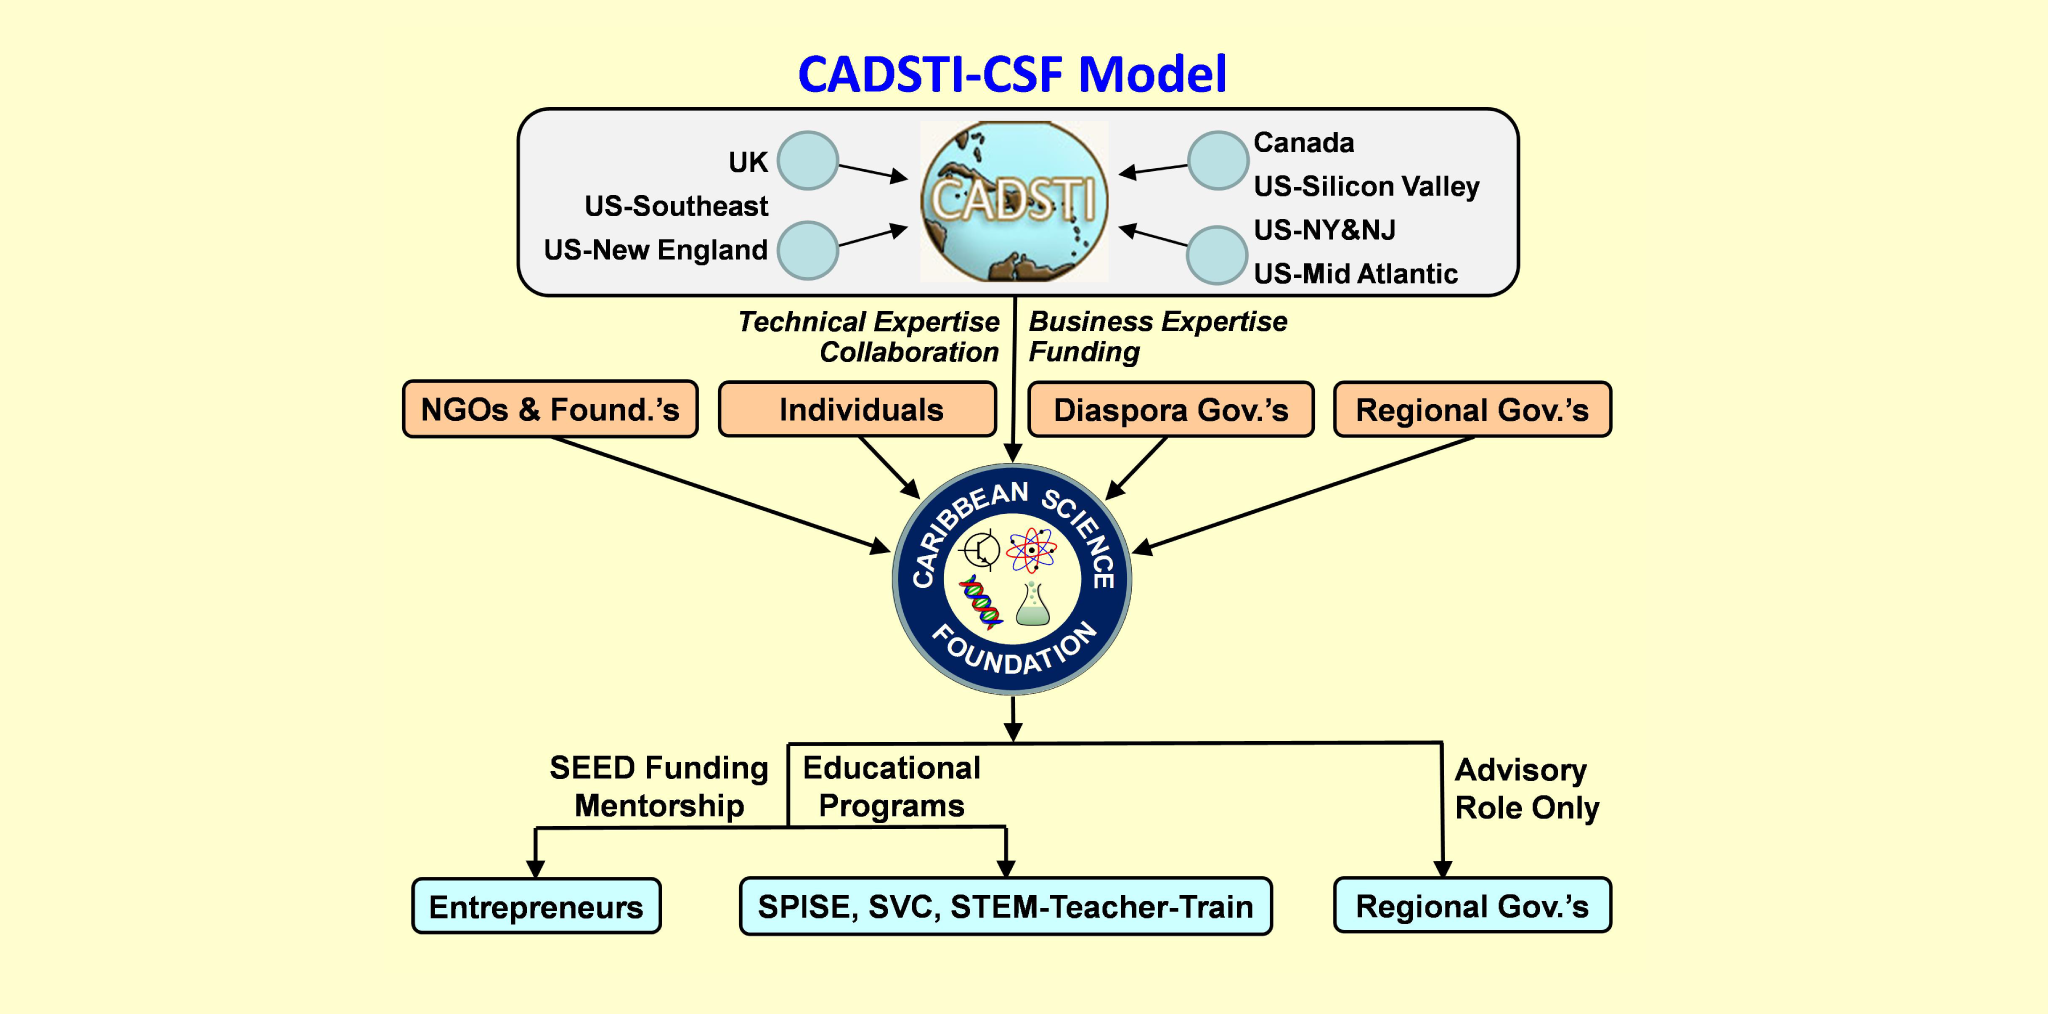How might the inclusion of STEM-Teacher-Train programs impact the overall mission of the Caribbean Science Foundation? The inclusion of STEM-Teacher-Train programs is pivotal to the mission of the Caribbean Science Foundation as it ensures that educators are well-equipped to impart advanced scientific knowledge to students. By training teachers, the CSF not only enhances the quality of science education but also ensures sustainability by creating a ripple effect. Well-trained teachers can inspire and cultivate future generations of scientists and innovators, amplifying the foundation's impact across the region long-term. 